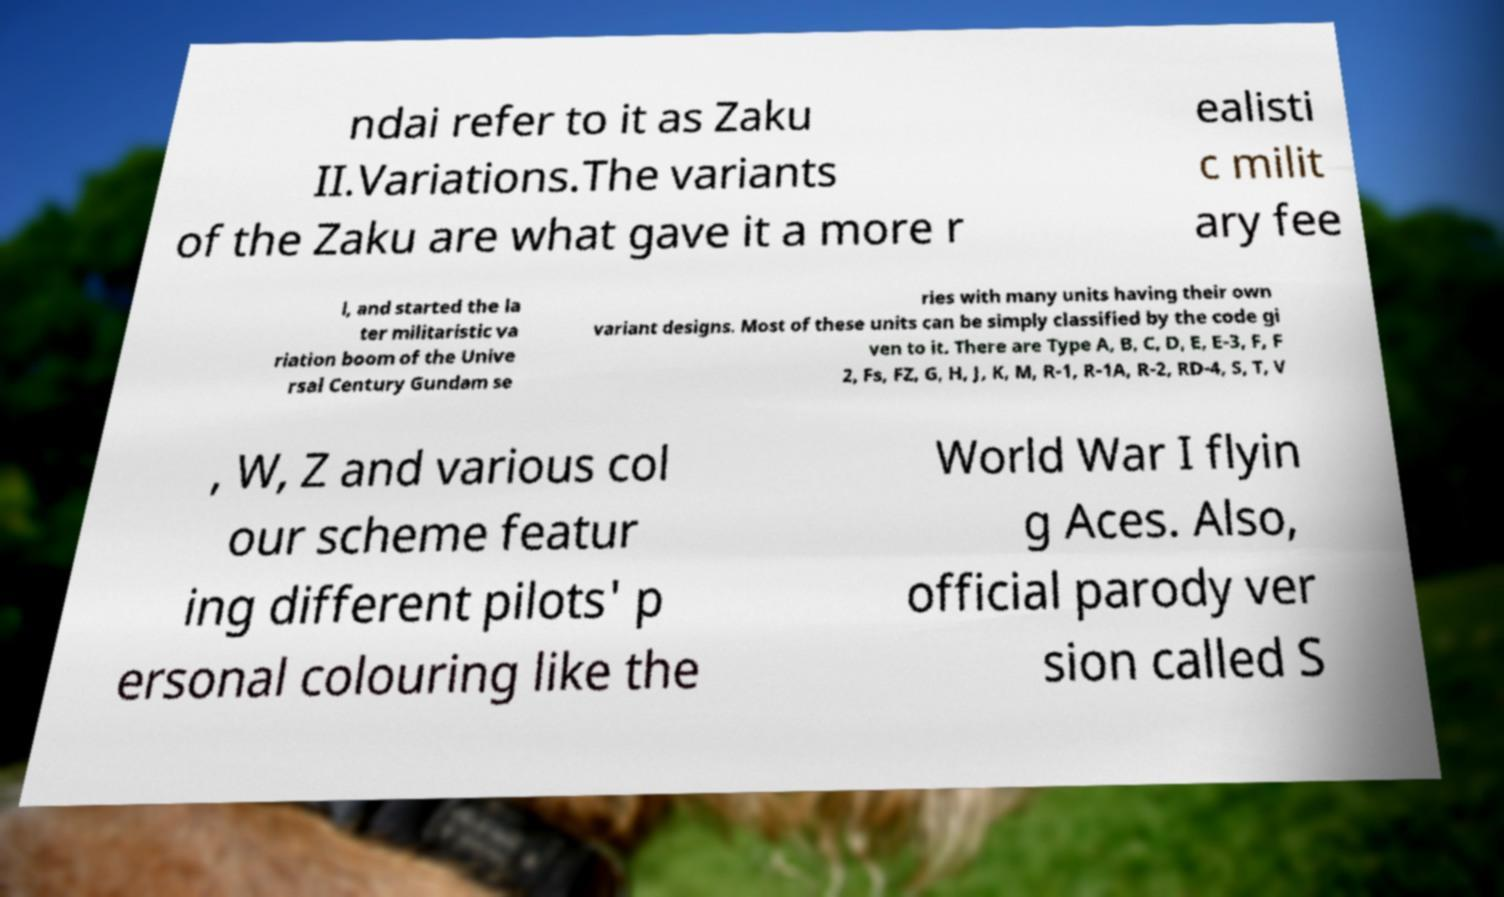Could you assist in decoding the text presented in this image and type it out clearly? ndai refer to it as Zaku II.Variations.The variants of the Zaku are what gave it a more r ealisti c milit ary fee l, and started the la ter militaristic va riation boom of the Unive rsal Century Gundam se ries with many units having their own variant designs. Most of these units can be simply classified by the code gi ven to it. There are Type A, B, C, D, E, E-3, F, F 2, Fs, FZ, G, H, J, K, M, R-1, R-1A, R-2, RD-4, S, T, V , W, Z and various col our scheme featur ing different pilots' p ersonal colouring like the World War I flyin g Aces. Also, official parody ver sion called S 